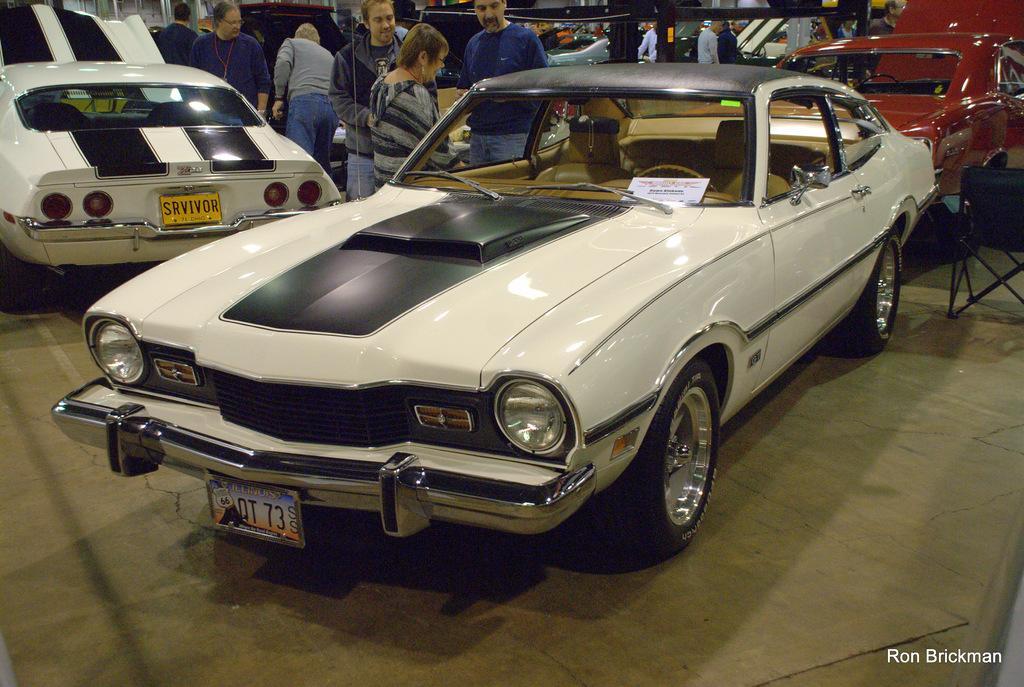Could you give a brief overview of what you see in this image? In this image we can see many vehicles. There is a chair at the left side of the image. There are many people in the image. There is a name board on the car in the image. There is some text at the bottom of the image. 